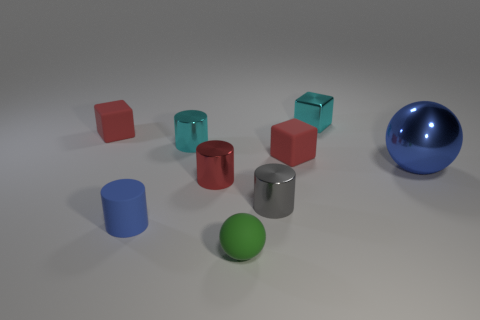Add 1 gray cylinders. How many objects exist? 10 Add 5 small green spheres. How many small green spheres exist? 6 Subtract all cyan cubes. How many cubes are left? 2 Subtract all red rubber cubes. How many cubes are left? 1 Subtract 1 blue balls. How many objects are left? 8 Subtract all cylinders. How many objects are left? 5 Subtract 3 cubes. How many cubes are left? 0 Subtract all yellow spheres. Subtract all green cubes. How many spheres are left? 2 Subtract all brown cylinders. How many gray balls are left? 0 Subtract all tiny red rubber objects. Subtract all metal blocks. How many objects are left? 6 